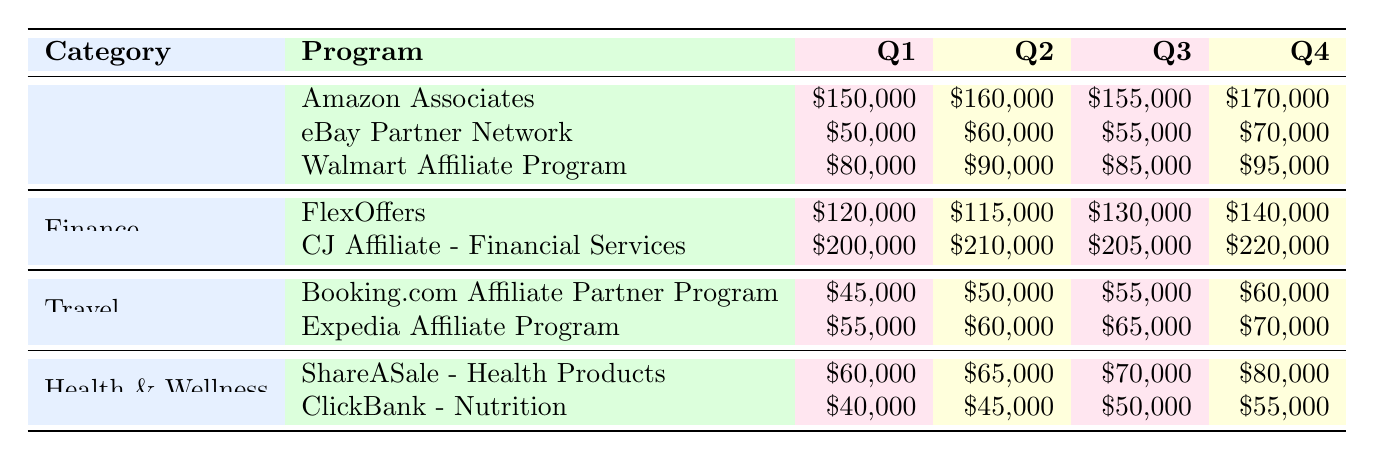What are the total earnings of Amazon Associates for the year? To find the total earnings for Amazon Associates, add the earnings from each quarter: Q1 (150000) + Q2 (160000) + Q3 (155000) + Q4 (170000) = 635000.
Answer: 635000 Which affiliate program in the Finance category had the highest earnings in Q2? In the Finance category, FlexOffers earned 115000 in Q2 and CJ Affiliate - Financial Services earned 210000. CJ Affiliate has the highest earnings in Q2.
Answer: Yes What was the percentage increase in earnings for the Walmart Affiliate Program from Q1 to Q4? The earnings in Q1 for Walmart was 80000 and in Q4 it was 95000. The increase is 95000 - 80000 = 15000. The percentage increase is (15000 / 80000) * 100 = 18.75%.
Answer: 18.75% Which category generated the highest total earnings in Q3? To find total earnings in Q3 across categories: E-commerce (155000) + Finance (205000) + Travel (65000) + Health & Wellness (50000) = 480000. Finance has the highest earnings in Q3 with 205000.
Answer: Finance Did the ShareASale - Health Products program earn more or less than the Expedia Affiliate Program in Q4? In Q4, ShareASale earned 80000 and Expedia earned 70000. Since 80000 > 70000, ShareASale earned more.
Answer: Yes What is the average quarterly earnings for the Travel category? The quarterly earnings for Booking.com are Q1 (45000), Q2 (50000), Q3 (55000), Q4 (60000) and for Expedia they are Q1 (55000), Q2 (60000), Q3 (65000), Q4 (70000). Total for Travel = 45000 + 50000 + 55000 + 60000 + 55000 + 60000 + 65000 + 70000 = 410000. There are 8 data points, so the average is 410000 / 8 = 51250.
Answer: 51250 Which program had the highest quarterly earnings in Q1? The earnings in Q1 for all programs are: Amazon Associates (150000), eBay (50000), Walmart (80000), FlexOffers (120000), CJ Affiliate (200000), Booking.com (45000), Expedia (55000), ShareASale (60000), ClickBank (40000). The highest is CJ Affiliate with 200000.
Answer: CJ Affiliate - Financial Services What is the total earnings difference between the highest and lowest program in Q4? In Q4, CJ Affiliate earned 220000 (highest) and ClickBank earned 55000 (lowest). The difference is 220000 - 55000 = 165000.
Answer: 165000 